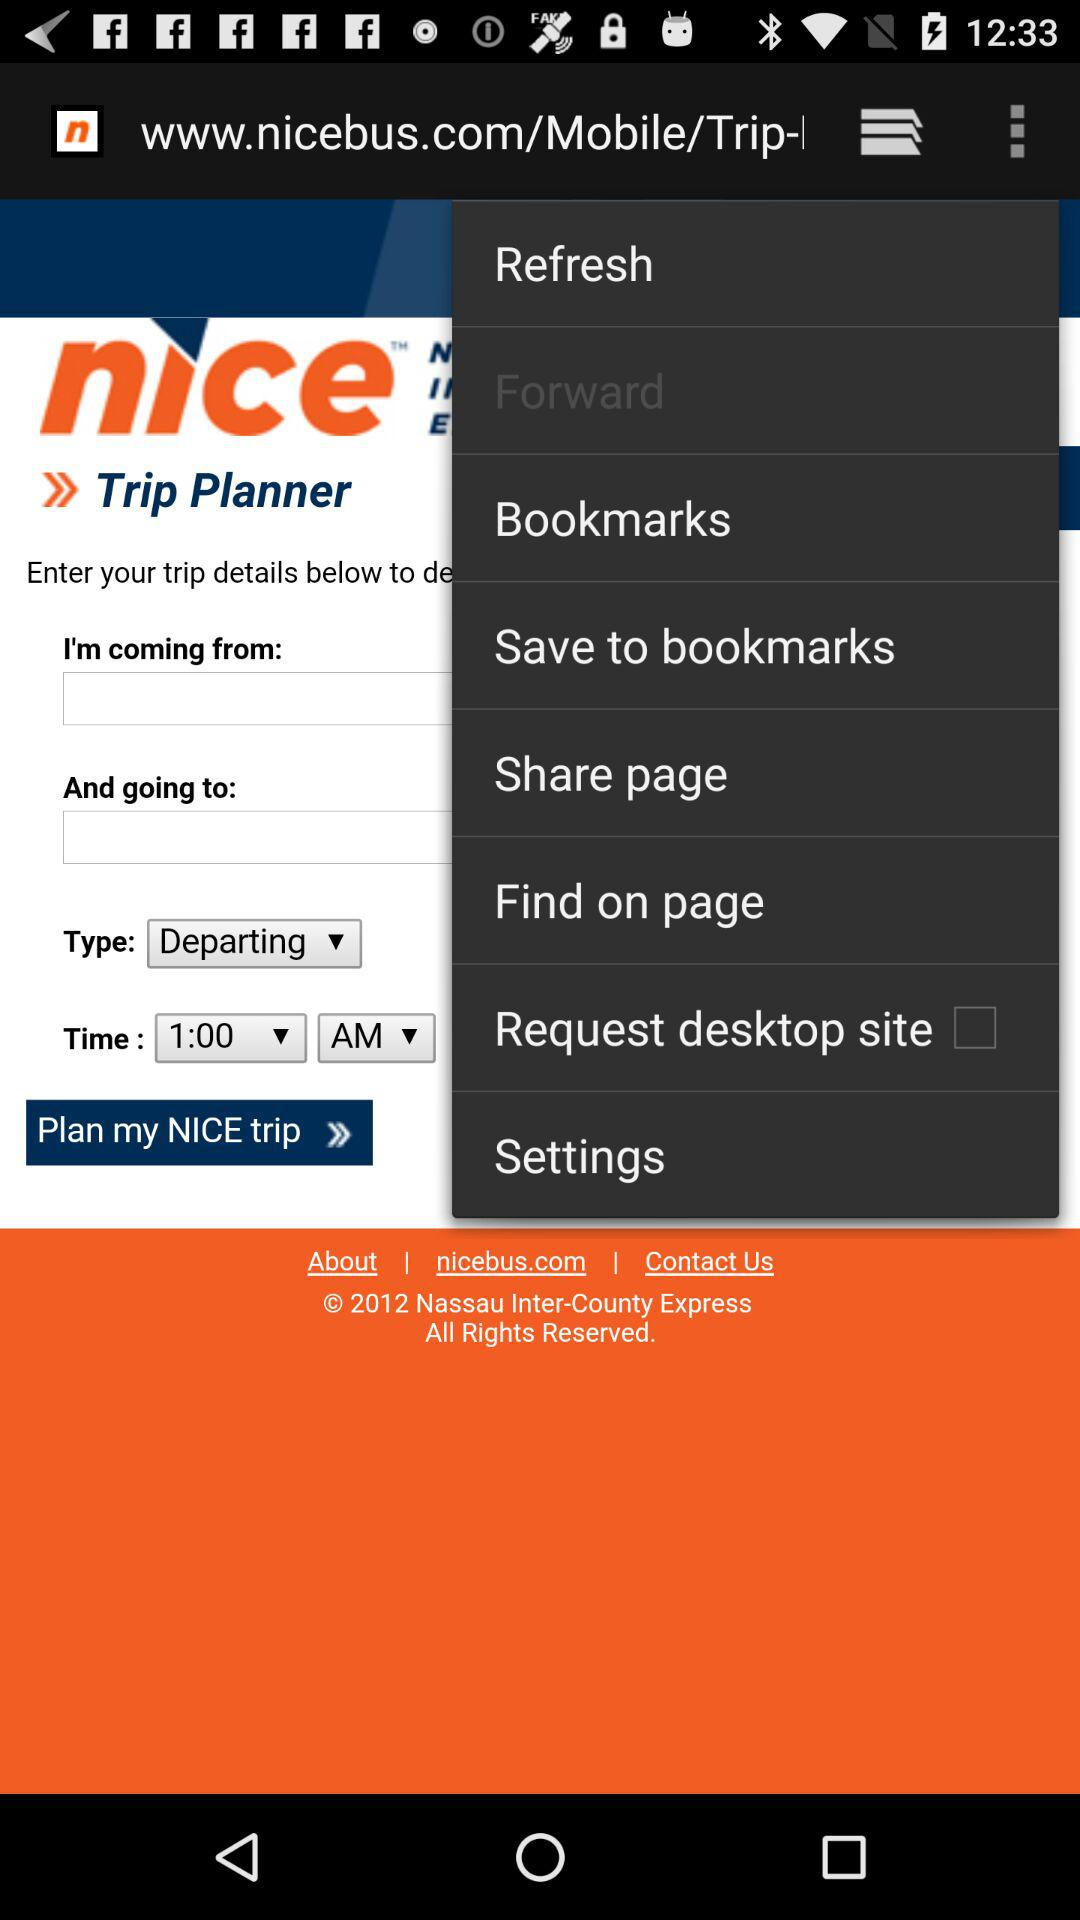What is the year of copyright for the application? The year of copyright for the application is 2012. 